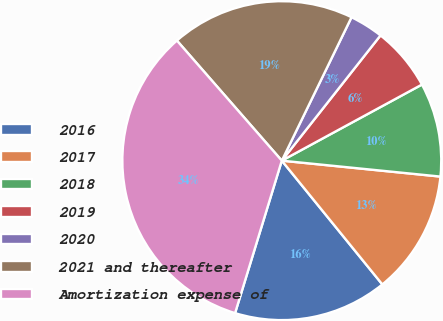Convert chart. <chart><loc_0><loc_0><loc_500><loc_500><pie_chart><fcel>2016<fcel>2017<fcel>2018<fcel>2019<fcel>2020<fcel>2021 and thereafter<fcel>Amortization expense of<nl><fcel>15.59%<fcel>12.55%<fcel>9.51%<fcel>6.46%<fcel>3.42%<fcel>18.63%<fcel>33.84%<nl></chart> 